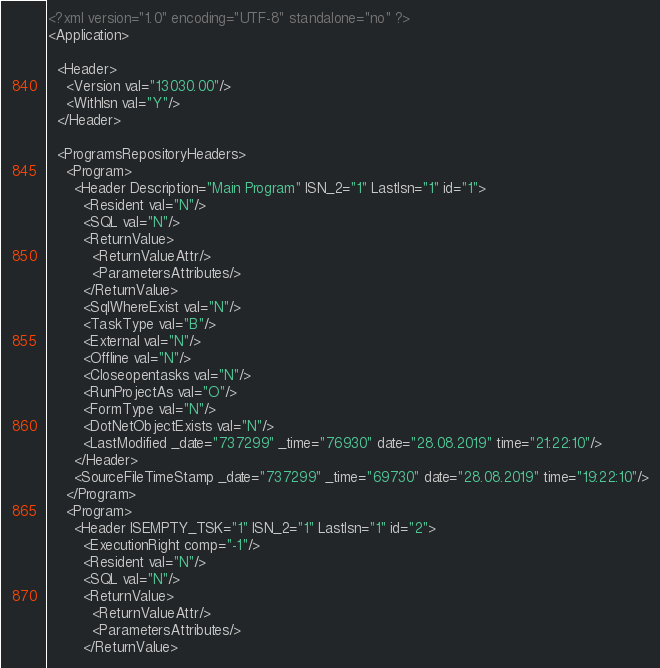Convert code to text. <code><loc_0><loc_0><loc_500><loc_500><_XML_><?xml version="1.0" encoding="UTF-8" standalone="no" ?>
<Application>

  <Header>
    <Version val="13030.00"/>
    <WithIsn val="Y"/>
  </Header>

  <ProgramsRepositoryHeaders>
    <Program>
      <Header Description="Main Program" ISN_2="1" LastIsn="1" id="1">
        <Resident val="N"/>
        <SQL val="N"/>
        <ReturnValue>
          <ReturnValueAttr/>
          <ParametersAttributes/>
        </ReturnValue>
        <SqlWhereExist val="N"/>
        <TaskType val="B"/>
        <External val="N"/>
        <Offline val="N"/>
        <Closeopentasks val="N"/>
        <RunProjectAs val="O"/>
        <FormType val="N"/>
        <DotNetObjectExists val="N"/>
        <LastModified _date="737299" _time="76930" date="28.08.2019" time="21:22:10"/>
      </Header>
      <SourceFileTimeStamp _date="737299" _time="69730" date="28.08.2019" time="19:22:10"/>
    </Program>
    <Program>
      <Header ISEMPTY_TSK="1" ISN_2="1" LastIsn="1" id="2">
        <ExecutionRight comp="-1"/>
        <Resident val="N"/>
        <SQL val="N"/>
        <ReturnValue>
          <ReturnValueAttr/>
          <ParametersAttributes/>
        </ReturnValue></code> 